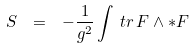Convert formula to latex. <formula><loc_0><loc_0><loc_500><loc_500>S \ = \ - \frac { 1 } { g ^ { 2 } } \int \, t r \, F \wedge * F</formula> 